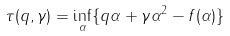<formula> <loc_0><loc_0><loc_500><loc_500>\tau ( q , \gamma ) = \inf _ { \alpha } \{ q \alpha + \gamma \alpha ^ { 2 } - f ( \alpha ) \}</formula> 